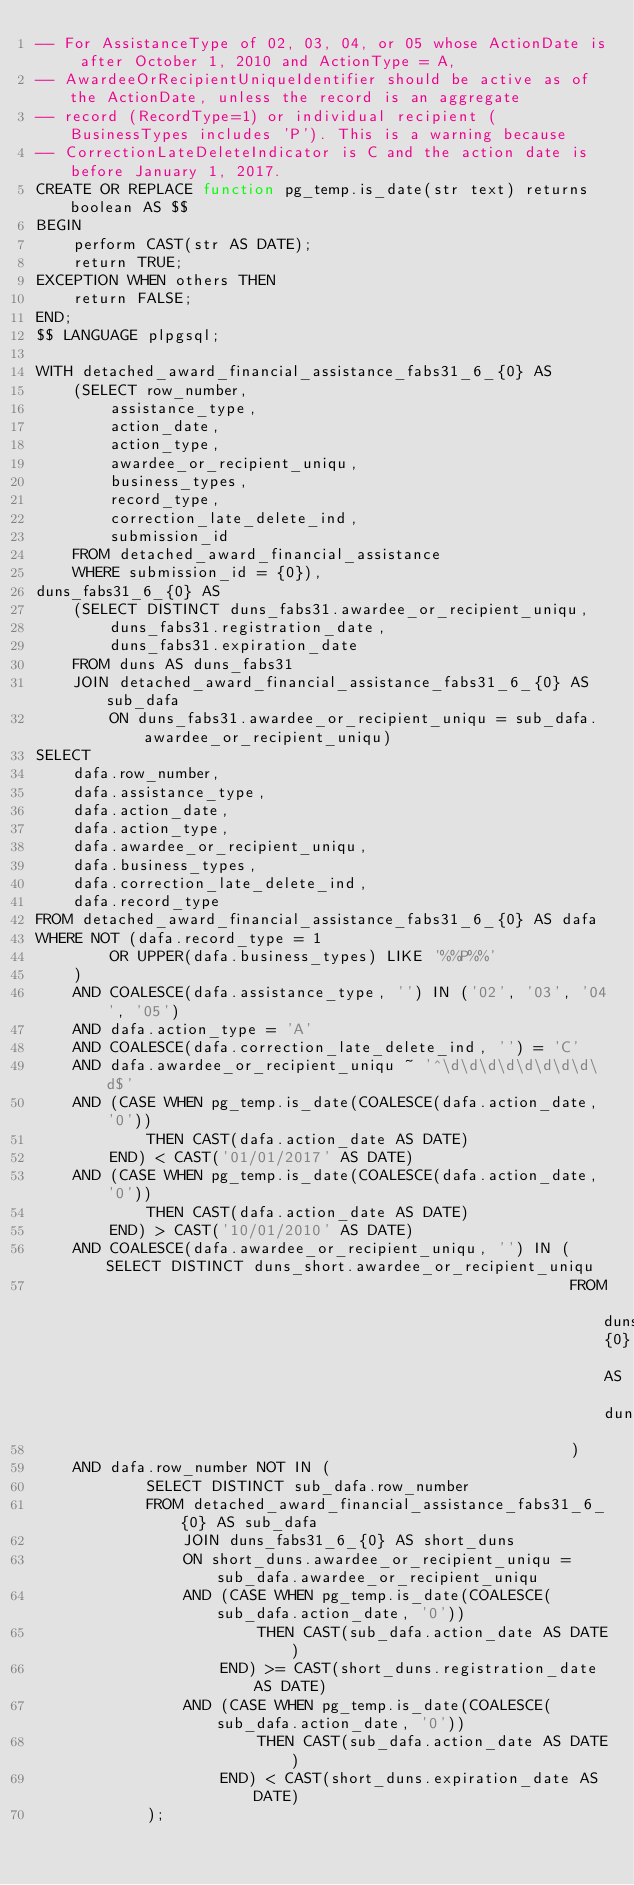<code> <loc_0><loc_0><loc_500><loc_500><_SQL_>-- For AssistanceType of 02, 03, 04, or 05 whose ActionDate is after October 1, 2010 and ActionType = A,
-- AwardeeOrRecipientUniqueIdentifier should be active as of the ActionDate, unless the record is an aggregate
-- record (RecordType=1) or individual recipient (BusinessTypes includes 'P'). This is a warning because
-- CorrectionLateDeleteIndicator is C and the action date is before January 1, 2017.
CREATE OR REPLACE function pg_temp.is_date(str text) returns boolean AS $$
BEGIN
    perform CAST(str AS DATE);
    return TRUE;
EXCEPTION WHEN others THEN
    return FALSE;
END;
$$ LANGUAGE plpgsql;

WITH detached_award_financial_assistance_fabs31_6_{0} AS
    (SELECT row_number,
        assistance_type,
        action_date,
        action_type,
        awardee_or_recipient_uniqu,
        business_types,
        record_type,
        correction_late_delete_ind,
        submission_id
    FROM detached_award_financial_assistance
    WHERE submission_id = {0}),
duns_fabs31_6_{0} AS
    (SELECT DISTINCT duns_fabs31.awardee_or_recipient_uniqu,
        duns_fabs31.registration_date,
        duns_fabs31.expiration_date
    FROM duns AS duns_fabs31
    JOIN detached_award_financial_assistance_fabs31_6_{0} AS sub_dafa
        ON duns_fabs31.awardee_or_recipient_uniqu = sub_dafa.awardee_or_recipient_uniqu)
SELECT
    dafa.row_number,
    dafa.assistance_type,
    dafa.action_date,
    dafa.action_type,
    dafa.awardee_or_recipient_uniqu,
    dafa.business_types,
    dafa.correction_late_delete_ind,
    dafa.record_type
FROM detached_award_financial_assistance_fabs31_6_{0} AS dafa
WHERE NOT (dafa.record_type = 1
        OR UPPER(dafa.business_types) LIKE '%%P%%'
    )
    AND COALESCE(dafa.assistance_type, '') IN ('02', '03', '04', '05')
    AND dafa.action_type = 'A'
    AND COALESCE(dafa.correction_late_delete_ind, '') = 'C'
    AND dafa.awardee_or_recipient_uniqu ~ '^\d\d\d\d\d\d\d\d\d$'
    AND (CASE WHEN pg_temp.is_date(COALESCE(dafa.action_date, '0'))
            THEN CAST(dafa.action_date AS DATE)
        END) < CAST('01/01/2017' AS DATE)
    AND (CASE WHEN pg_temp.is_date(COALESCE(dafa.action_date, '0'))
            THEN CAST(dafa.action_date AS DATE)
        END) > CAST('10/01/2010' AS DATE)
    AND COALESCE(dafa.awardee_or_recipient_uniqu, '') IN (SELECT DISTINCT duns_short.awardee_or_recipient_uniqu
                                                          FROM duns_fabs31_6_{0} AS duns_short
                                                          )
    AND dafa.row_number NOT IN (
            SELECT DISTINCT sub_dafa.row_number
            FROM detached_award_financial_assistance_fabs31_6_{0} AS sub_dafa
                JOIN duns_fabs31_6_{0} AS short_duns
                ON short_duns.awardee_or_recipient_uniqu = sub_dafa.awardee_or_recipient_uniqu
                AND (CASE WHEN pg_temp.is_date(COALESCE(sub_dafa.action_date, '0'))
                        THEN CAST(sub_dafa.action_date AS DATE)
                    END) >= CAST(short_duns.registration_date AS DATE)
                AND (CASE WHEN pg_temp.is_date(COALESCE(sub_dafa.action_date, '0'))
                        THEN CAST(sub_dafa.action_date AS DATE)
                    END) < CAST(short_duns.expiration_date AS DATE)
            );
</code> 